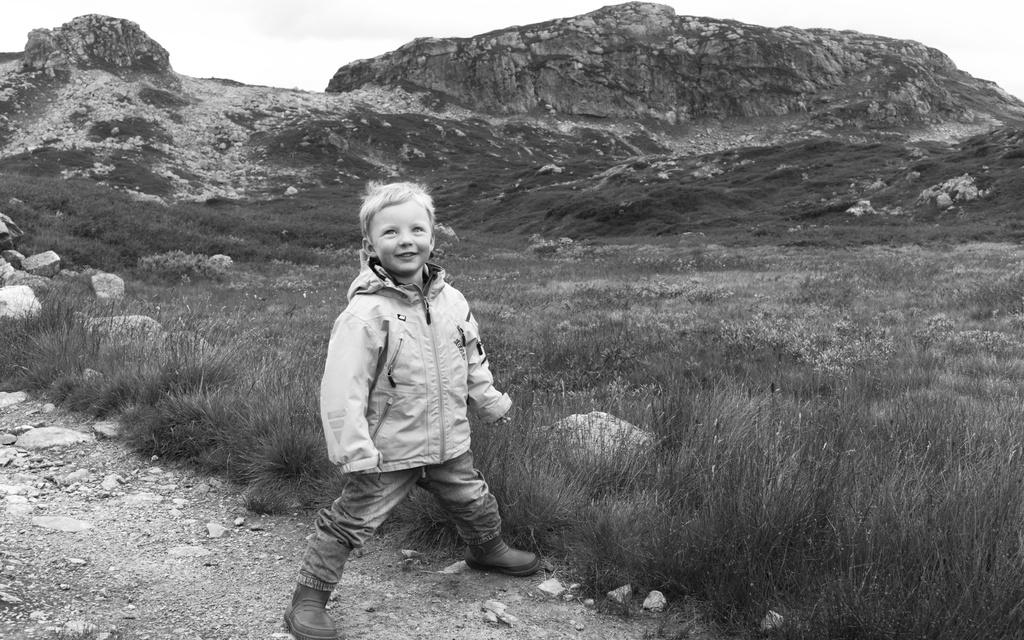What is the main subject of the image? There is a boy standing in the image. What is the boy's expression in the image? The boy is smiling in the image. What type of terrain is visible in the image? There is grass on the ground and rocks in the image. What geographical feature is present in the image? There is a hill in the image. What is the weather like in the image? The sky is cloudy in the image. What type of ornament is hanging from the icicle in the image? There is no ornament or icicle present in the image. What causes the shock in the image? There is no shock or indication of a shocking event in the image. 